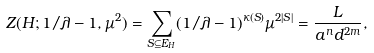Convert formula to latex. <formula><loc_0><loc_0><loc_500><loc_500>Z ( H ; 1 / \lambda - 1 , \mu ^ { 2 } ) = \sum _ { S \subseteq E _ { H } } ( 1 / \lambda - 1 ) ^ { \kappa ( S ) } \mu ^ { 2 | S | } = \frac { L } { a ^ { n } d ^ { 2 m } } ,</formula> 